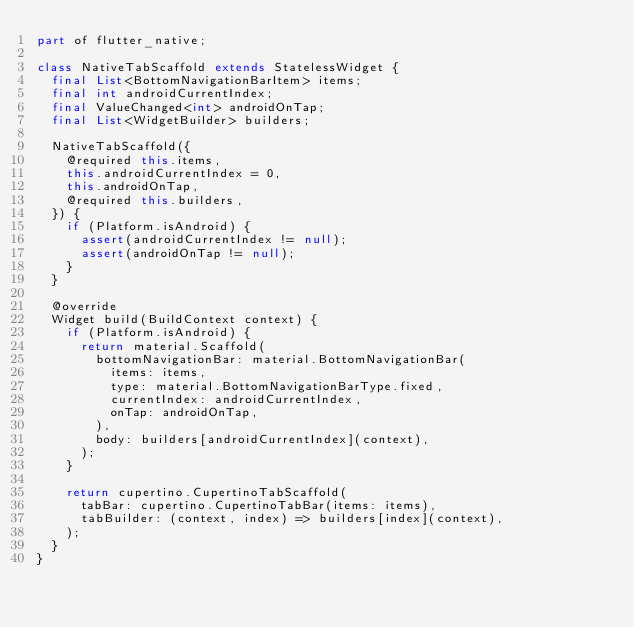Convert code to text. <code><loc_0><loc_0><loc_500><loc_500><_Dart_>part of flutter_native;

class NativeTabScaffold extends StatelessWidget {
  final List<BottomNavigationBarItem> items;
  final int androidCurrentIndex;
  final ValueChanged<int> androidOnTap;
  final List<WidgetBuilder> builders;

  NativeTabScaffold({
    @required this.items,
    this.androidCurrentIndex = 0,
    this.androidOnTap,
    @required this.builders,
  }) {
    if (Platform.isAndroid) {
      assert(androidCurrentIndex != null);
      assert(androidOnTap != null);
    }
  }

  @override
  Widget build(BuildContext context) {
    if (Platform.isAndroid) {
      return material.Scaffold(
        bottomNavigationBar: material.BottomNavigationBar(
          items: items,
          type: material.BottomNavigationBarType.fixed,
          currentIndex: androidCurrentIndex,
          onTap: androidOnTap,
        ),
        body: builders[androidCurrentIndex](context),
      );
    }

    return cupertino.CupertinoTabScaffold(
      tabBar: cupertino.CupertinoTabBar(items: items),
      tabBuilder: (context, index) => builders[index](context),
    );
  }
}
</code> 